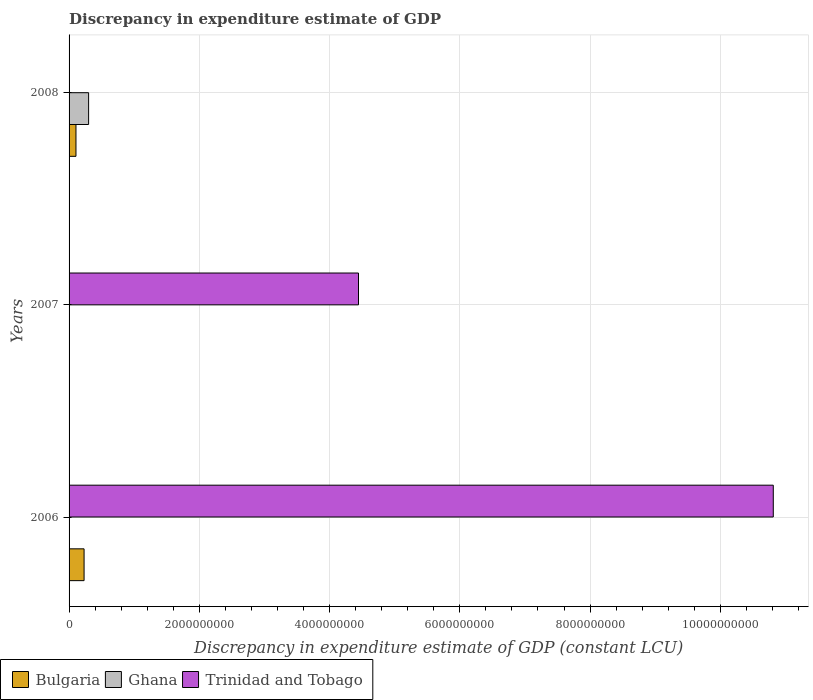Are the number of bars on each tick of the Y-axis equal?
Ensure brevity in your answer.  No. How many bars are there on the 1st tick from the bottom?
Keep it short and to the point. 3. What is the label of the 3rd group of bars from the top?
Provide a succinct answer. 2006. In how many cases, is the number of bars for a given year not equal to the number of legend labels?
Provide a short and direct response. 2. What is the discrepancy in expenditure estimate of GDP in Bulgaria in 2006?
Offer a terse response. 2.30e+08. Across all years, what is the maximum discrepancy in expenditure estimate of GDP in Trinidad and Tobago?
Your response must be concise. 1.08e+1. Across all years, what is the minimum discrepancy in expenditure estimate of GDP in Ghana?
Give a very brief answer. 0. What is the total discrepancy in expenditure estimate of GDP in Bulgaria in the graph?
Make the answer very short. 3.36e+08. What is the difference between the discrepancy in expenditure estimate of GDP in Ghana in 2006 and that in 2008?
Provide a succinct answer. -3.00e+08. What is the difference between the discrepancy in expenditure estimate of GDP in Ghana in 2008 and the discrepancy in expenditure estimate of GDP in Trinidad and Tobago in 2007?
Offer a very short reply. -4.14e+09. What is the average discrepancy in expenditure estimate of GDP in Trinidad and Tobago per year?
Ensure brevity in your answer.  5.09e+09. In the year 2006, what is the difference between the discrepancy in expenditure estimate of GDP in Trinidad and Tobago and discrepancy in expenditure estimate of GDP in Ghana?
Provide a short and direct response. 1.08e+1. In how many years, is the discrepancy in expenditure estimate of GDP in Bulgaria greater than 5200000000 LCU?
Give a very brief answer. 0. What is the ratio of the discrepancy in expenditure estimate of GDP in Trinidad and Tobago in 2006 to that in 2007?
Provide a succinct answer. 2.43. Is the discrepancy in expenditure estimate of GDP in Trinidad and Tobago in 2006 less than that in 2007?
Give a very brief answer. No. What is the difference between the highest and the lowest discrepancy in expenditure estimate of GDP in Bulgaria?
Your answer should be very brief. 2.30e+08. In how many years, is the discrepancy in expenditure estimate of GDP in Ghana greater than the average discrepancy in expenditure estimate of GDP in Ghana taken over all years?
Offer a very short reply. 1. Is it the case that in every year, the sum of the discrepancy in expenditure estimate of GDP in Ghana and discrepancy in expenditure estimate of GDP in Bulgaria is greater than the discrepancy in expenditure estimate of GDP in Trinidad and Tobago?
Make the answer very short. No. How many bars are there?
Your answer should be compact. 6. Are all the bars in the graph horizontal?
Provide a succinct answer. Yes. How many years are there in the graph?
Give a very brief answer. 3. Does the graph contain any zero values?
Ensure brevity in your answer.  Yes. Where does the legend appear in the graph?
Your answer should be compact. Bottom left. What is the title of the graph?
Keep it short and to the point. Discrepancy in expenditure estimate of GDP. What is the label or title of the X-axis?
Give a very brief answer. Discrepancy in expenditure estimate of GDP (constant LCU). What is the label or title of the Y-axis?
Provide a succinct answer. Years. What is the Discrepancy in expenditure estimate of GDP (constant LCU) of Bulgaria in 2006?
Keep it short and to the point. 2.30e+08. What is the Discrepancy in expenditure estimate of GDP (constant LCU) in Ghana in 2006?
Ensure brevity in your answer.  504.75. What is the Discrepancy in expenditure estimate of GDP (constant LCU) of Trinidad and Tobago in 2006?
Offer a terse response. 1.08e+1. What is the Discrepancy in expenditure estimate of GDP (constant LCU) of Ghana in 2007?
Offer a very short reply. 0. What is the Discrepancy in expenditure estimate of GDP (constant LCU) of Trinidad and Tobago in 2007?
Offer a terse response. 4.44e+09. What is the Discrepancy in expenditure estimate of GDP (constant LCU) in Bulgaria in 2008?
Ensure brevity in your answer.  1.06e+08. What is the Discrepancy in expenditure estimate of GDP (constant LCU) in Ghana in 2008?
Make the answer very short. 3.00e+08. What is the Discrepancy in expenditure estimate of GDP (constant LCU) in Trinidad and Tobago in 2008?
Your answer should be compact. 0. Across all years, what is the maximum Discrepancy in expenditure estimate of GDP (constant LCU) in Bulgaria?
Provide a short and direct response. 2.30e+08. Across all years, what is the maximum Discrepancy in expenditure estimate of GDP (constant LCU) of Ghana?
Your response must be concise. 3.00e+08. Across all years, what is the maximum Discrepancy in expenditure estimate of GDP (constant LCU) in Trinidad and Tobago?
Provide a succinct answer. 1.08e+1. Across all years, what is the minimum Discrepancy in expenditure estimate of GDP (constant LCU) in Bulgaria?
Offer a terse response. 0. What is the total Discrepancy in expenditure estimate of GDP (constant LCU) in Bulgaria in the graph?
Keep it short and to the point. 3.36e+08. What is the total Discrepancy in expenditure estimate of GDP (constant LCU) in Ghana in the graph?
Provide a short and direct response. 3.00e+08. What is the total Discrepancy in expenditure estimate of GDP (constant LCU) in Trinidad and Tobago in the graph?
Provide a short and direct response. 1.53e+1. What is the difference between the Discrepancy in expenditure estimate of GDP (constant LCU) in Trinidad and Tobago in 2006 and that in 2007?
Offer a very short reply. 6.37e+09. What is the difference between the Discrepancy in expenditure estimate of GDP (constant LCU) in Bulgaria in 2006 and that in 2008?
Offer a very short reply. 1.24e+08. What is the difference between the Discrepancy in expenditure estimate of GDP (constant LCU) of Ghana in 2006 and that in 2008?
Offer a very short reply. -3.00e+08. What is the difference between the Discrepancy in expenditure estimate of GDP (constant LCU) of Bulgaria in 2006 and the Discrepancy in expenditure estimate of GDP (constant LCU) of Trinidad and Tobago in 2007?
Your answer should be compact. -4.21e+09. What is the difference between the Discrepancy in expenditure estimate of GDP (constant LCU) of Ghana in 2006 and the Discrepancy in expenditure estimate of GDP (constant LCU) of Trinidad and Tobago in 2007?
Keep it short and to the point. -4.44e+09. What is the difference between the Discrepancy in expenditure estimate of GDP (constant LCU) in Bulgaria in 2006 and the Discrepancy in expenditure estimate of GDP (constant LCU) in Ghana in 2008?
Ensure brevity in your answer.  -6.96e+07. What is the average Discrepancy in expenditure estimate of GDP (constant LCU) in Bulgaria per year?
Your response must be concise. 1.12e+08. What is the average Discrepancy in expenditure estimate of GDP (constant LCU) in Ghana per year?
Your response must be concise. 1.00e+08. What is the average Discrepancy in expenditure estimate of GDP (constant LCU) in Trinidad and Tobago per year?
Offer a very short reply. 5.09e+09. In the year 2006, what is the difference between the Discrepancy in expenditure estimate of GDP (constant LCU) in Bulgaria and Discrepancy in expenditure estimate of GDP (constant LCU) in Ghana?
Offer a terse response. 2.30e+08. In the year 2006, what is the difference between the Discrepancy in expenditure estimate of GDP (constant LCU) in Bulgaria and Discrepancy in expenditure estimate of GDP (constant LCU) in Trinidad and Tobago?
Your answer should be compact. -1.06e+1. In the year 2006, what is the difference between the Discrepancy in expenditure estimate of GDP (constant LCU) in Ghana and Discrepancy in expenditure estimate of GDP (constant LCU) in Trinidad and Tobago?
Offer a terse response. -1.08e+1. In the year 2008, what is the difference between the Discrepancy in expenditure estimate of GDP (constant LCU) in Bulgaria and Discrepancy in expenditure estimate of GDP (constant LCU) in Ghana?
Give a very brief answer. -1.94e+08. What is the ratio of the Discrepancy in expenditure estimate of GDP (constant LCU) in Trinidad and Tobago in 2006 to that in 2007?
Your response must be concise. 2.43. What is the ratio of the Discrepancy in expenditure estimate of GDP (constant LCU) of Bulgaria in 2006 to that in 2008?
Give a very brief answer. 2.17. What is the ratio of the Discrepancy in expenditure estimate of GDP (constant LCU) of Ghana in 2006 to that in 2008?
Your answer should be very brief. 0. What is the difference between the highest and the lowest Discrepancy in expenditure estimate of GDP (constant LCU) in Bulgaria?
Make the answer very short. 2.30e+08. What is the difference between the highest and the lowest Discrepancy in expenditure estimate of GDP (constant LCU) in Ghana?
Give a very brief answer. 3.00e+08. What is the difference between the highest and the lowest Discrepancy in expenditure estimate of GDP (constant LCU) in Trinidad and Tobago?
Make the answer very short. 1.08e+1. 